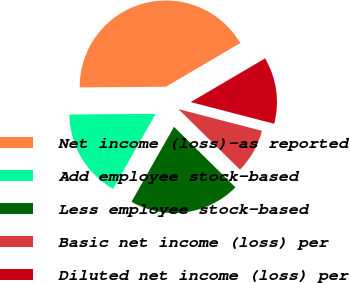Convert chart to OTSL. <chart><loc_0><loc_0><loc_500><loc_500><pie_chart><fcel>Net income (loss)-as reported<fcel>Add employee stock-based<fcel>Less employee stock-based<fcel>Basic net income (loss) per<fcel>Diluted net income (loss) per<nl><fcel>41.67%<fcel>16.67%<fcel>20.83%<fcel>8.33%<fcel>12.5%<nl></chart> 